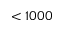<formula> <loc_0><loc_0><loc_500><loc_500>< 1 0 0 0</formula> 